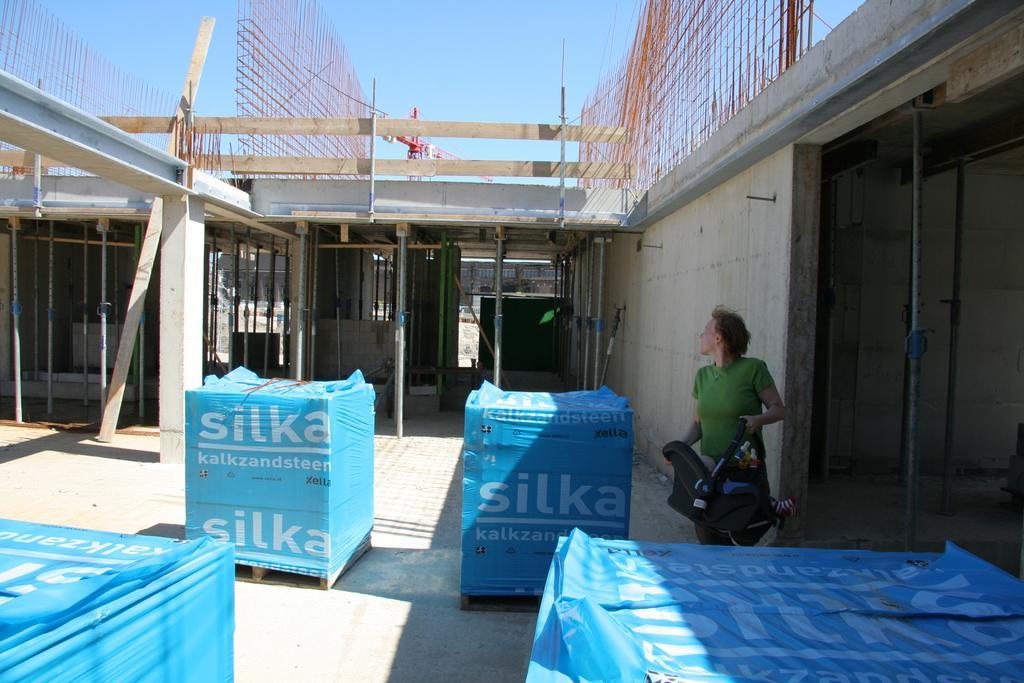In one or two sentences, can you explain what this image depicts? In the picture I can see the packed boxes on the floor. There is a person on the right side holding something in the hands. I can see a construction tower crane. I can see the wooden blocks. There are clouds in the sky. 